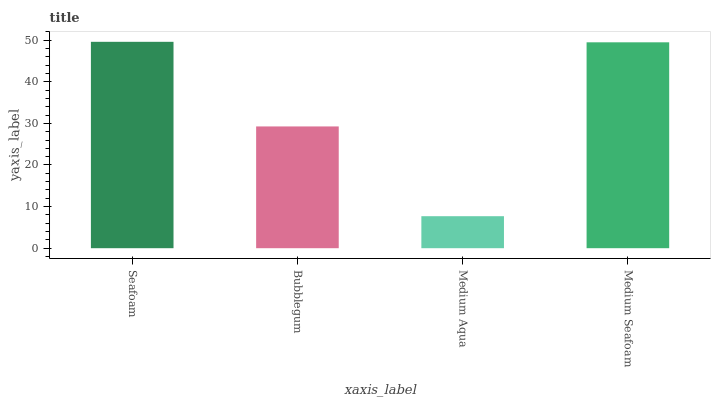Is Medium Aqua the minimum?
Answer yes or no. Yes. Is Seafoam the maximum?
Answer yes or no. Yes. Is Bubblegum the minimum?
Answer yes or no. No. Is Bubblegum the maximum?
Answer yes or no. No. Is Seafoam greater than Bubblegum?
Answer yes or no. Yes. Is Bubblegum less than Seafoam?
Answer yes or no. Yes. Is Bubblegum greater than Seafoam?
Answer yes or no. No. Is Seafoam less than Bubblegum?
Answer yes or no. No. Is Medium Seafoam the high median?
Answer yes or no. Yes. Is Bubblegum the low median?
Answer yes or no. Yes. Is Seafoam the high median?
Answer yes or no. No. Is Medium Aqua the low median?
Answer yes or no. No. 